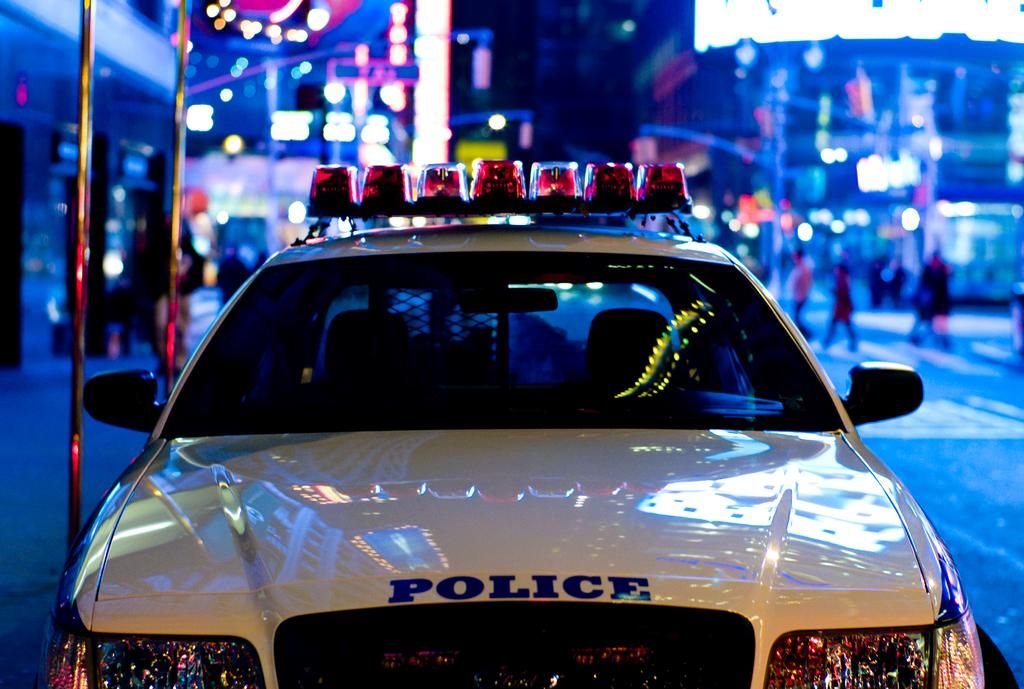What is the main subject of the image? The main subject of the image is a police car. What is located behind the police car? There are rods behind the police car. What type of structures can be seen in the image? Buildings are visible in the image. What kind of lights are present in the image? Lights and street lights are visible in the image. What additional items can be seen in the image? Posters are present in the image. Are there any people in the image? Yes, there is a group of people in the image. What type of quartz can be seen in the image? There is no quartz present in the image. How does the cave in the image affect the visibility of the police car? There is no cave present in the image, so it does not affect the visibility of the police car. 